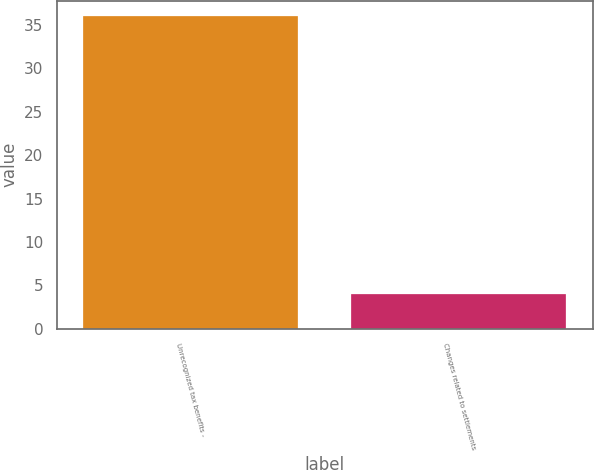<chart> <loc_0><loc_0><loc_500><loc_500><bar_chart><fcel>Unrecognized tax benefits -<fcel>Changes related to settlements<nl><fcel>36<fcel>4<nl></chart> 